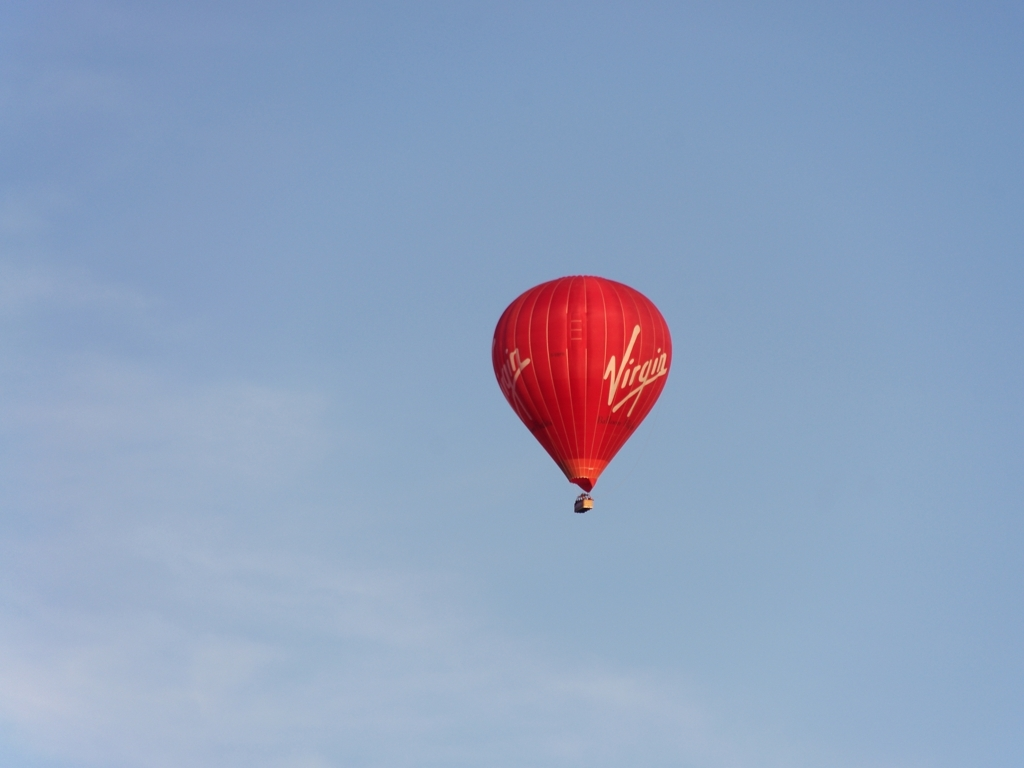Is there anything that can be inferred about the time of day from this image? The sky is clear and has a hue that suggests it could be late morning or early afternoon. The visibility is excellent, as there are no signs of the warm colors often associated with sunrise or sunset. What can we say about the weather conditions in the image? The weather looks favorable for hot air ballooning, with clear skies and no visible clouds, indicating low wind speeds and stable atmospheric conditions, which are ideal for this activity. 